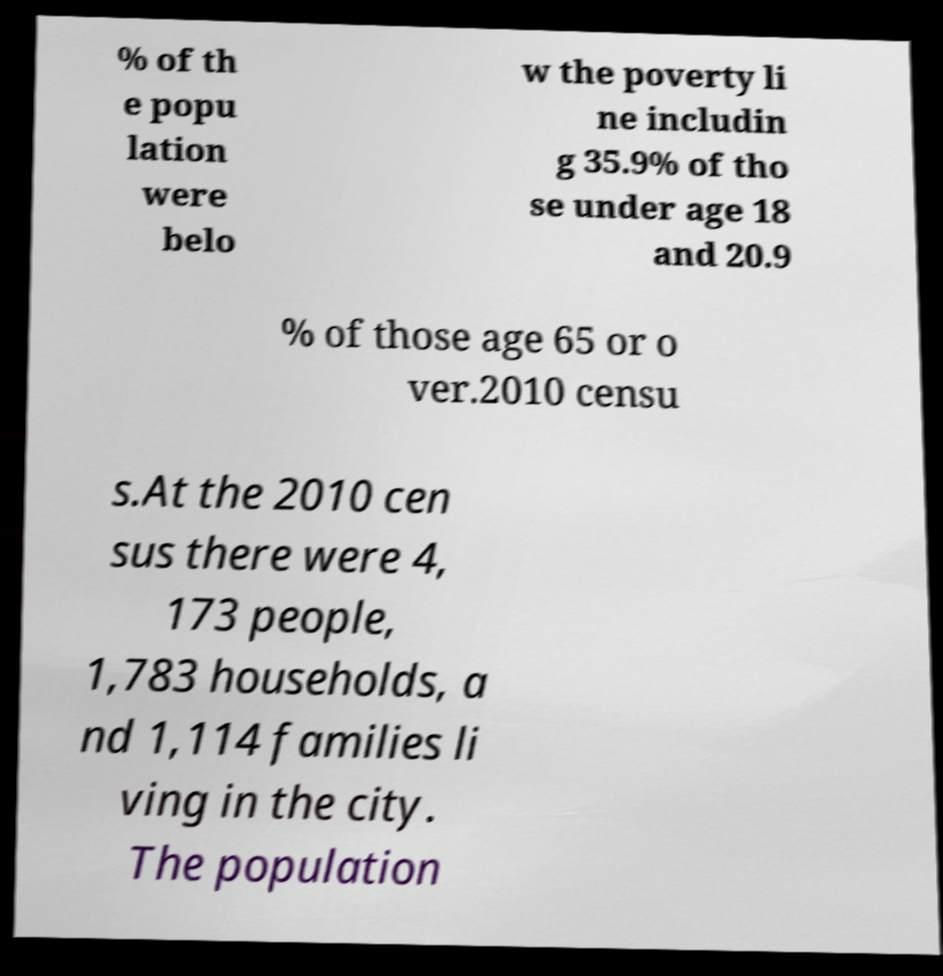Could you assist in decoding the text presented in this image and type it out clearly? % of th e popu lation were belo w the poverty li ne includin g 35.9% of tho se under age 18 and 20.9 % of those age 65 or o ver.2010 censu s.At the 2010 cen sus there were 4, 173 people, 1,783 households, a nd 1,114 families li ving in the city. The population 